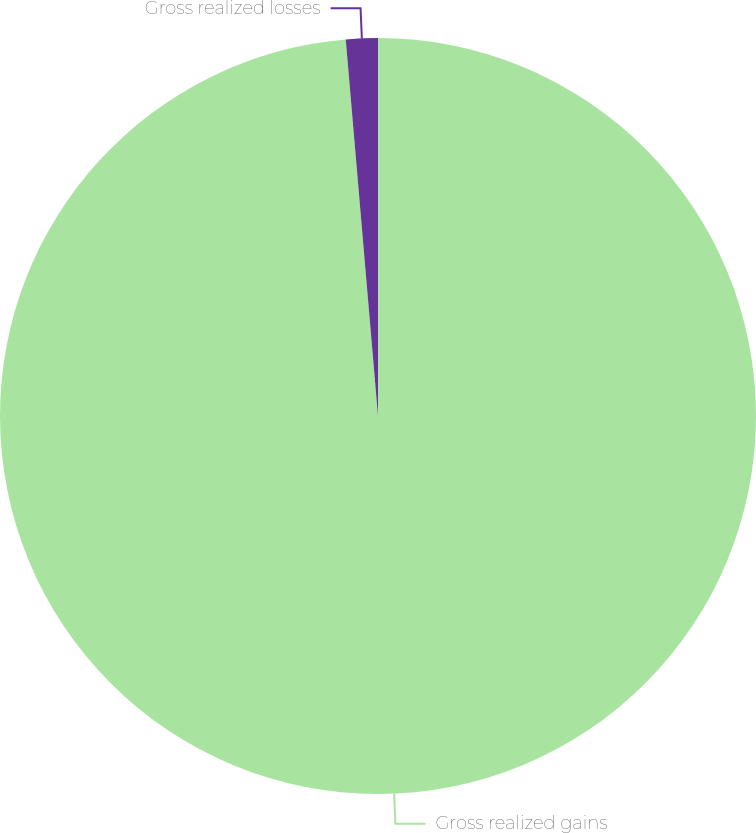Convert chart to OTSL. <chart><loc_0><loc_0><loc_500><loc_500><pie_chart><fcel>Gross realized gains<fcel>Gross realized losses<nl><fcel>98.64%<fcel>1.36%<nl></chart> 